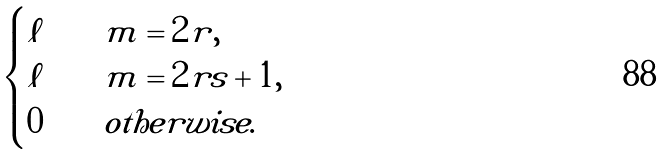Convert formula to latex. <formula><loc_0><loc_0><loc_500><loc_500>\begin{cases} \ell & \quad m = 2 r , \\ \ell & \quad m = 2 r s + 1 , \\ 0 & \quad o t h e r w i s e . \end{cases}</formula> 